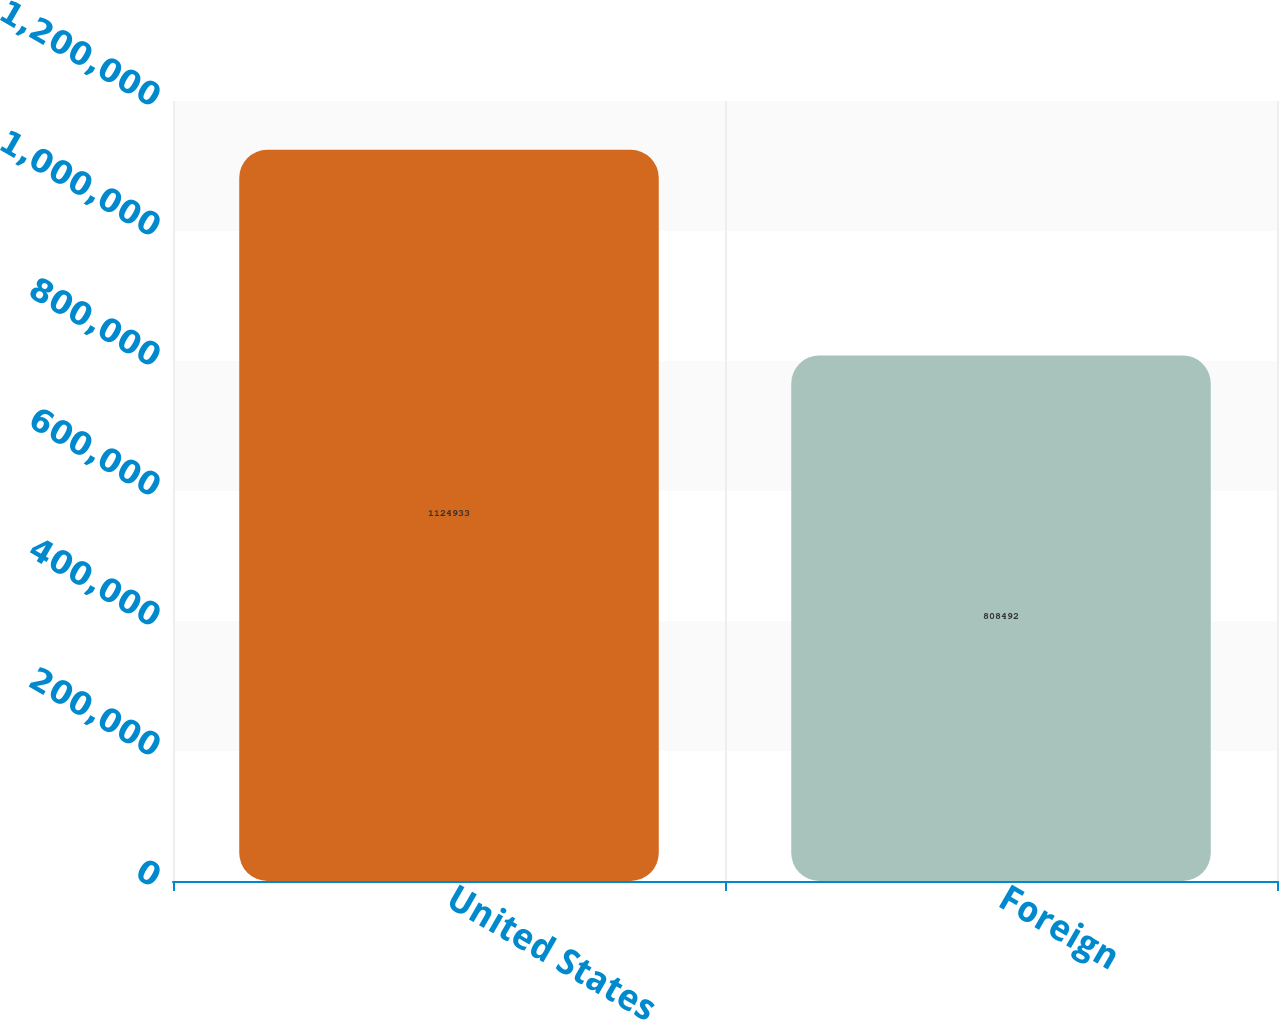<chart> <loc_0><loc_0><loc_500><loc_500><bar_chart><fcel>United States<fcel>Foreign<nl><fcel>1.12493e+06<fcel>808492<nl></chart> 